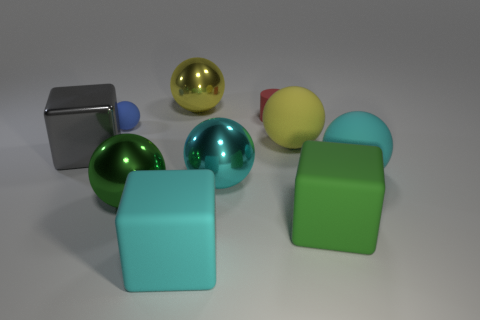How many big spheres are there?
Your response must be concise. 5. What number of green things are tiny matte cylinders or large cylinders?
Offer a terse response. 0. What number of other objects are the same shape as the green metal thing?
Keep it short and to the point. 5. Is the color of the large metal object that is right of the cyan rubber block the same as the big matte cube on the left side of the tiny matte cylinder?
Your answer should be very brief. Yes. What number of large things are rubber cylinders or gray rubber cubes?
Your response must be concise. 0. What is the size of the green shiny thing that is the same shape as the large yellow matte object?
Your response must be concise. Large. What is the small thing that is to the left of the large yellow metal ball on the left side of the cyan rubber ball made of?
Keep it short and to the point. Rubber. What number of metal things are large gray objects or tiny cylinders?
Keep it short and to the point. 1. The other big rubber object that is the same shape as the large green matte thing is what color?
Ensure brevity in your answer.  Cyan. What number of other rubber cylinders have the same color as the matte cylinder?
Give a very brief answer. 0. 